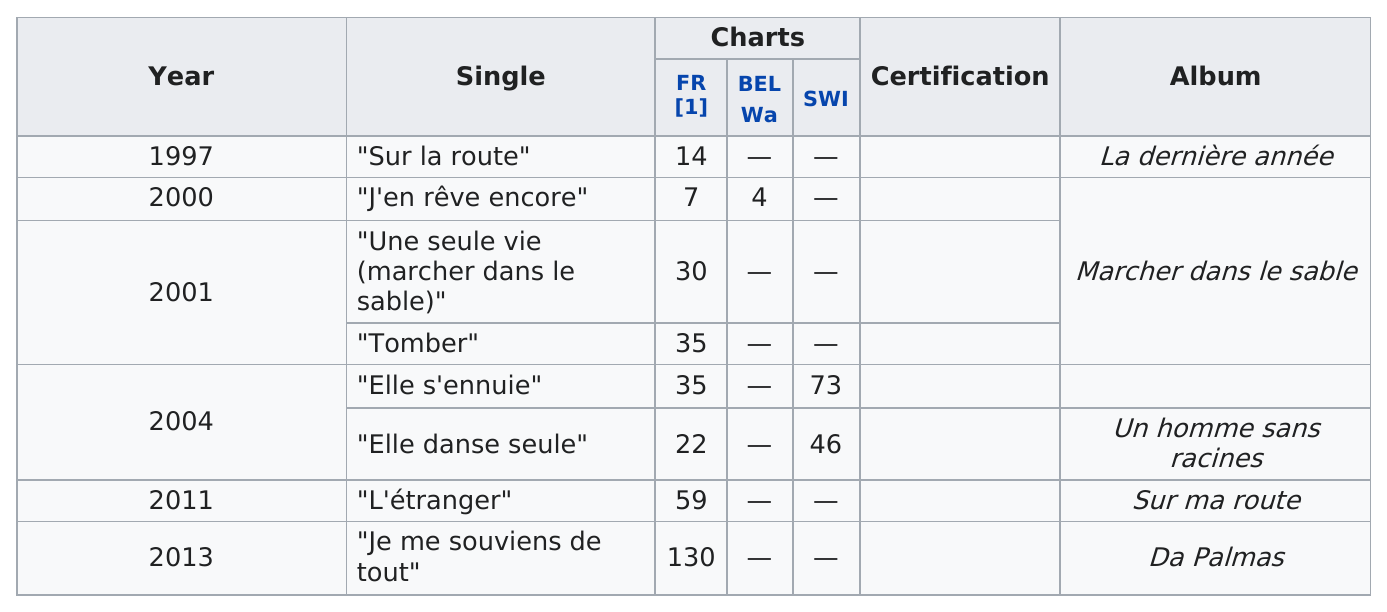Identify some key points in this picture. In total, 8 singles were released. The single that was released after "Tomber" was "Elle s'ennuie. Sur la route" was the first song to reach the French charts. I remember everything, including the most recent single released, which was 'Je me souviens de tout'. Out of the total number of songs that were not listed on the Swiss Charts, approximately 6 songs were not included. 